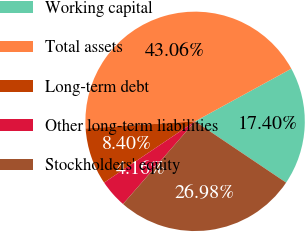Convert chart to OTSL. <chart><loc_0><loc_0><loc_500><loc_500><pie_chart><fcel>Working capital<fcel>Total assets<fcel>Long-term debt<fcel>Other long-term liabilities<fcel>Stockholders' equity<nl><fcel>17.4%<fcel>43.06%<fcel>8.4%<fcel>4.16%<fcel>26.98%<nl></chart> 